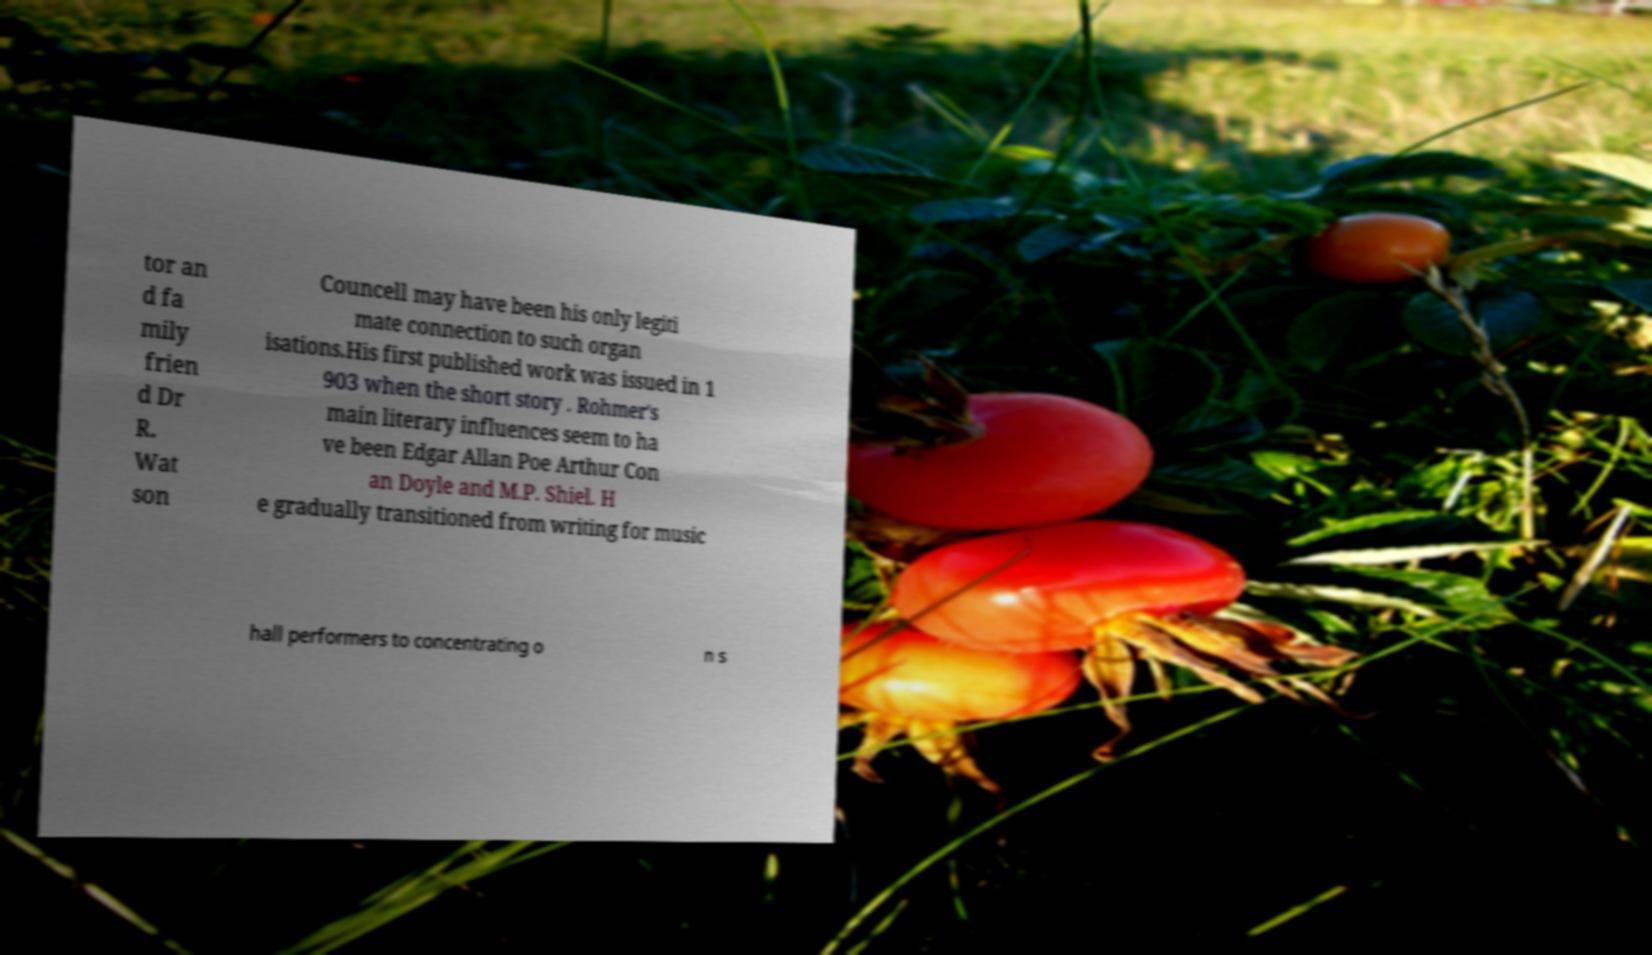Could you extract and type out the text from this image? tor an d fa mily frien d Dr R. Wat son Councell may have been his only legiti mate connection to such organ isations.His first published work was issued in 1 903 when the short story . Rohmer's main literary influences seem to ha ve been Edgar Allan Poe Arthur Con an Doyle and M.P. Shiel. H e gradually transitioned from writing for music hall performers to concentrating o n s 